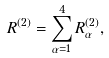Convert formula to latex. <formula><loc_0><loc_0><loc_500><loc_500>R ^ { ( 2 ) } = \sum _ { \alpha = 1 } ^ { 4 } R _ { \alpha } ^ { ( 2 ) } ,</formula> 